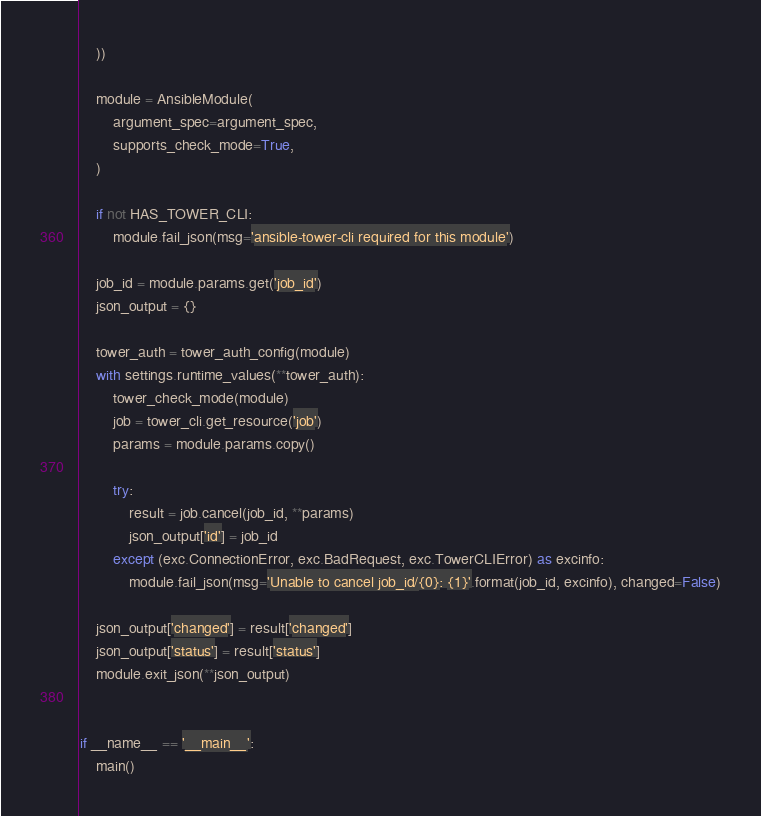Convert code to text. <code><loc_0><loc_0><loc_500><loc_500><_Python_>    ))

    module = AnsibleModule(
        argument_spec=argument_spec,
        supports_check_mode=True,
    )

    if not HAS_TOWER_CLI:
        module.fail_json(msg='ansible-tower-cli required for this module')

    job_id = module.params.get('job_id')
    json_output = {}

    tower_auth = tower_auth_config(module)
    with settings.runtime_values(**tower_auth):
        tower_check_mode(module)
        job = tower_cli.get_resource('job')
        params = module.params.copy()

        try:
            result = job.cancel(job_id, **params)
            json_output['id'] = job_id
        except (exc.ConnectionError, exc.BadRequest, exc.TowerCLIError) as excinfo:
            module.fail_json(msg='Unable to cancel job_id/{0}: {1}'.format(job_id, excinfo), changed=False)

    json_output['changed'] = result['changed']
    json_output['status'] = result['status']
    module.exit_json(**json_output)


if __name__ == '__main__':
    main()
</code> 